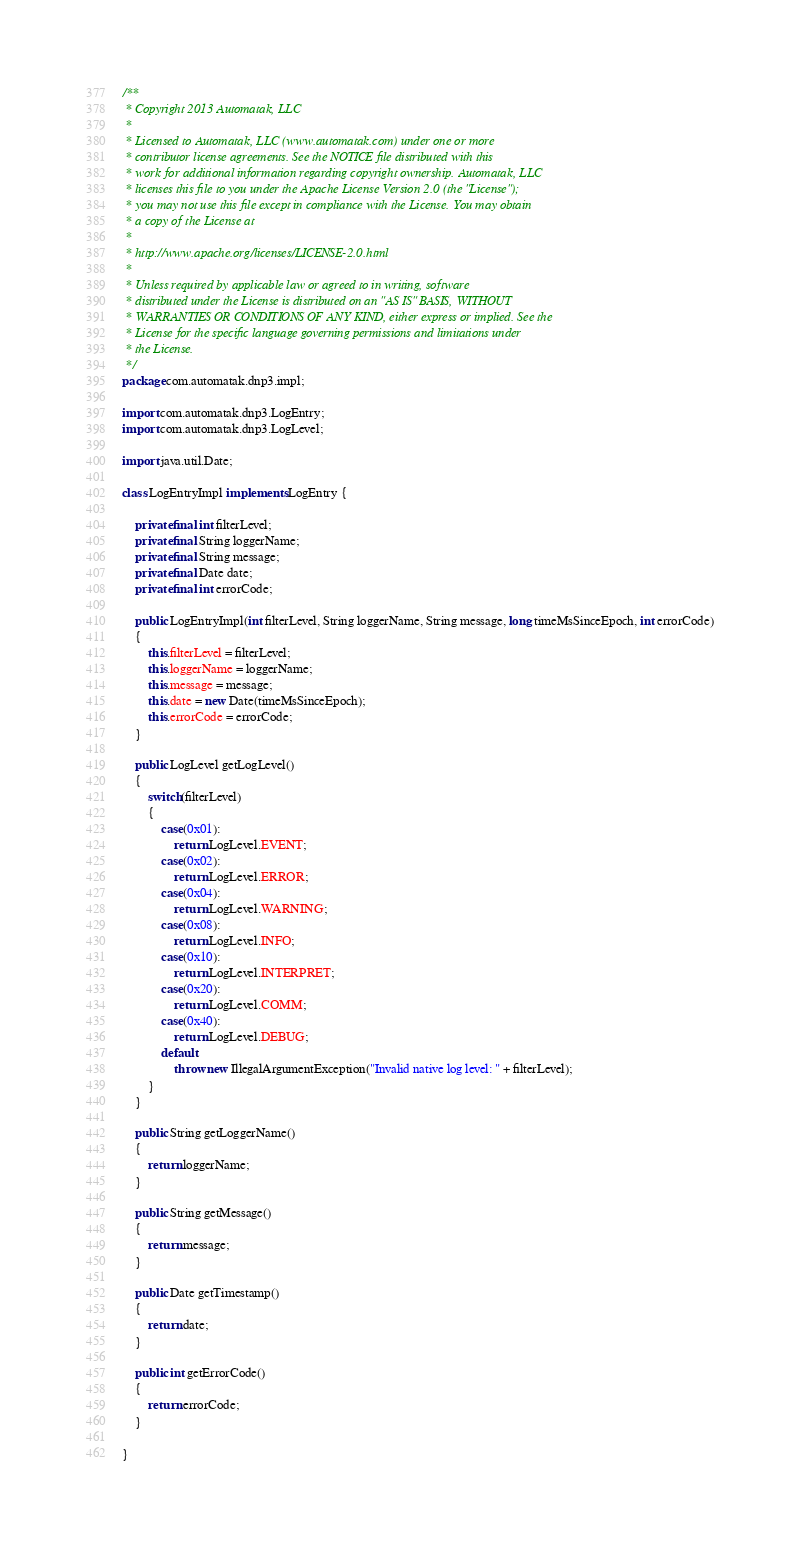<code> <loc_0><loc_0><loc_500><loc_500><_Java_>/**
 * Copyright 2013 Automatak, LLC
 *
 * Licensed to Automatak, LLC (www.automatak.com) under one or more
 * contributor license agreements. See the NOTICE file distributed with this
 * work for additional information regarding copyright ownership. Automatak, LLC
 * licenses this file to you under the Apache License Version 2.0 (the "License");
 * you may not use this file except in compliance with the License. You may obtain
 * a copy of the License at
 *
 * http://www.apache.org/licenses/LICENSE-2.0.html
 *
 * Unless required by applicable law or agreed to in writing, software
 * distributed under the License is distributed on an "AS IS" BASIS, WITHOUT
 * WARRANTIES OR CONDITIONS OF ANY KIND, either express or implied. See the
 * License for the specific language governing permissions and limitations under
 * the License.
 */
package com.automatak.dnp3.impl;

import com.automatak.dnp3.LogEntry;
import com.automatak.dnp3.LogLevel;

import java.util.Date;

class LogEntryImpl implements LogEntry {

    private final int filterLevel;
    private final String loggerName;
    private final String message;
    private final Date date;
    private final int errorCode;

    public LogEntryImpl(int filterLevel, String loggerName, String message, long timeMsSinceEpoch, int errorCode)
    {
        this.filterLevel = filterLevel;
        this.loggerName = loggerName;
        this.message = message;
        this.date = new Date(timeMsSinceEpoch);
        this.errorCode = errorCode;
    }

    public LogLevel getLogLevel()
    {
        switch(filterLevel)
        {
            case(0x01):
                return LogLevel.EVENT;
            case(0x02):
                return LogLevel.ERROR;
            case(0x04):
                return LogLevel.WARNING;
            case(0x08):
                return LogLevel.INFO;
            case(0x10):
                return LogLevel.INTERPRET;
            case(0x20):
                return LogLevel.COMM;
            case(0x40):
                return LogLevel.DEBUG;
            default:
                throw new IllegalArgumentException("Invalid native log level: " + filterLevel);
        }
    }

    public String getLoggerName()
    {
        return loggerName;
    }

    public String getMessage()
    {
        return message;
    }

    public Date getTimestamp()
    {
        return date;
    }

    public int getErrorCode()
    {
        return errorCode;
    }

}
</code> 